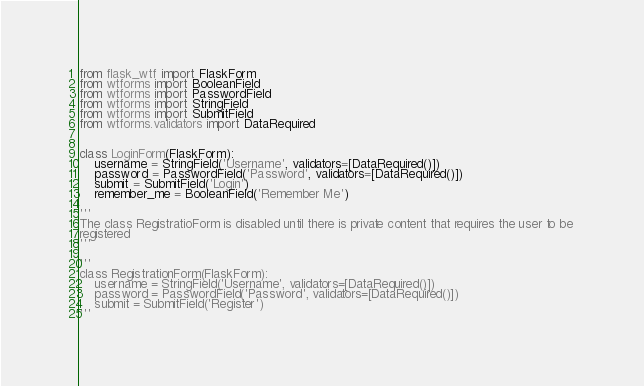<code> <loc_0><loc_0><loc_500><loc_500><_Python_>from flask_wtf import FlaskForm
from wtforms import BooleanField
from wtforms import PasswordField
from wtforms import StringField
from wtforms import SubmitField
from wtforms.validators import DataRequired


class LoginForm(FlaskForm):
    username = StringField('Username', validators=[DataRequired()])
    password = PasswordField('Password', validators=[DataRequired()])
    submit = SubmitField('Login')
    remember_me = BooleanField('Remember Me')

'''
The class RegistratioForm is disabled until there is private content that requires the user to be 
registered
'''

'''
class RegistrationForm(FlaskForm):
    username = StringField('Username', validators=[DataRequired()])
    password = PasswordField('Password', validators=[DataRequired()])
    submit = SubmitField('Register')
'''</code> 